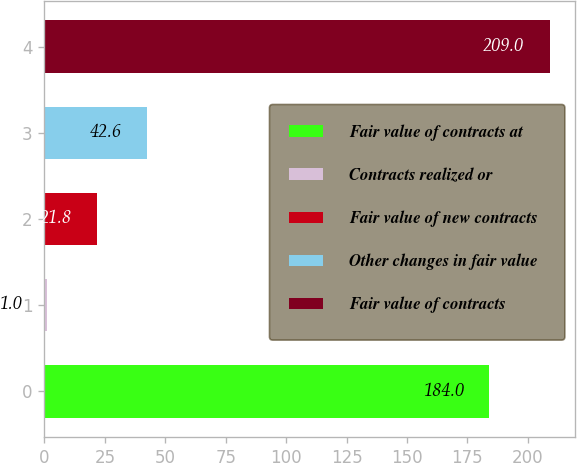Convert chart to OTSL. <chart><loc_0><loc_0><loc_500><loc_500><bar_chart><fcel>Fair value of contracts at<fcel>Contracts realized or<fcel>Fair value of new contracts<fcel>Other changes in fair value<fcel>Fair value of contracts<nl><fcel>184<fcel>1<fcel>21.8<fcel>42.6<fcel>209<nl></chart> 